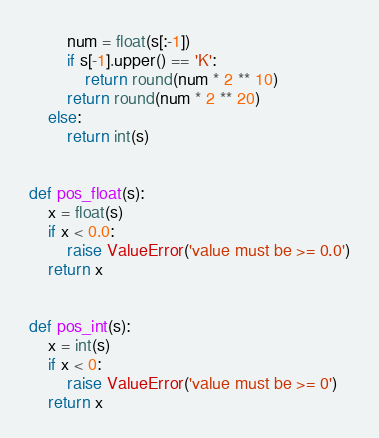Convert code to text. <code><loc_0><loc_0><loc_500><loc_500><_Python_>        num = float(s[:-1])
        if s[-1].upper() == 'K':
            return round(num * 2 ** 10)
        return round(num * 2 ** 20)
    else:
        return int(s)


def pos_float(s):
    x = float(s)
    if x < 0.0:
        raise ValueError('value must be >= 0.0')
    return x


def pos_int(s):
    x = int(s)
    if x < 0:
        raise ValueError('value must be >= 0')
    return x
</code> 